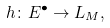<formula> <loc_0><loc_0><loc_500><loc_500>h \colon E ^ { \bullet } \to L _ { M } ,</formula> 